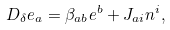Convert formula to latex. <formula><loc_0><loc_0><loc_500><loc_500>D _ { \delta } e _ { a } = \beta _ { a b } e ^ { b } + J _ { a i } n ^ { i } ,</formula> 